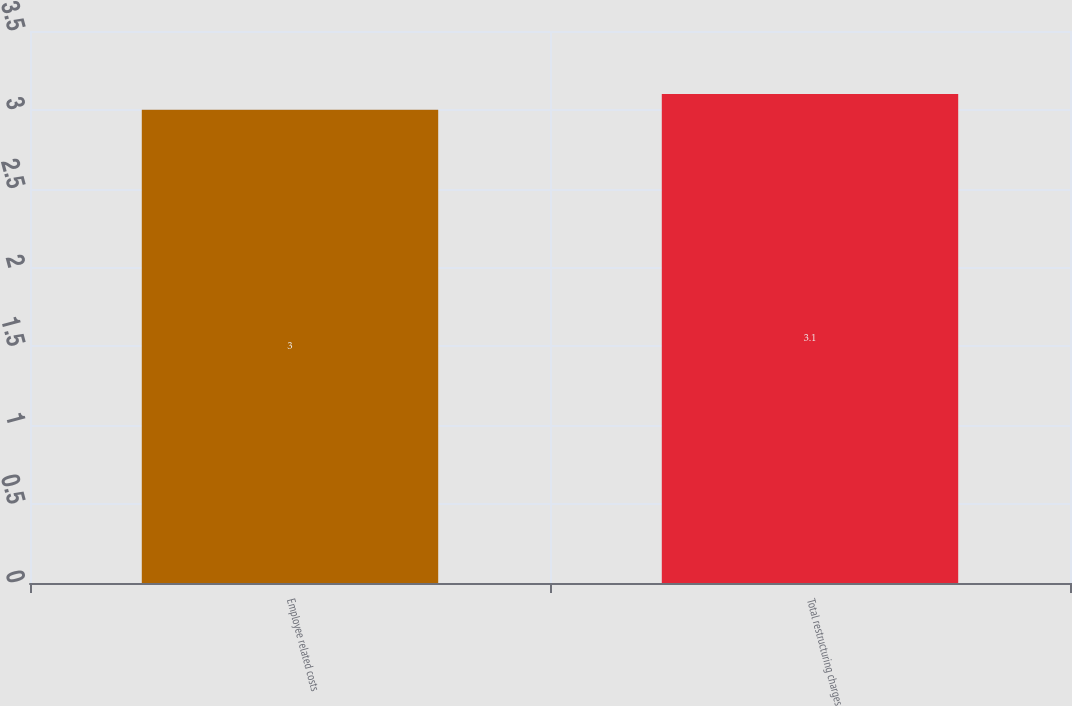Convert chart to OTSL. <chart><loc_0><loc_0><loc_500><loc_500><bar_chart><fcel>Employee related costs<fcel>Total restructuring charges<nl><fcel>3<fcel>3.1<nl></chart> 